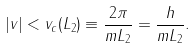Convert formula to latex. <formula><loc_0><loc_0><loc_500><loc_500>| v | < v _ { c } ( L _ { 2 } ) \equiv \frac { 2 \pi } { m L _ { 2 } } = \frac { h } { m L _ { 2 } } .</formula> 